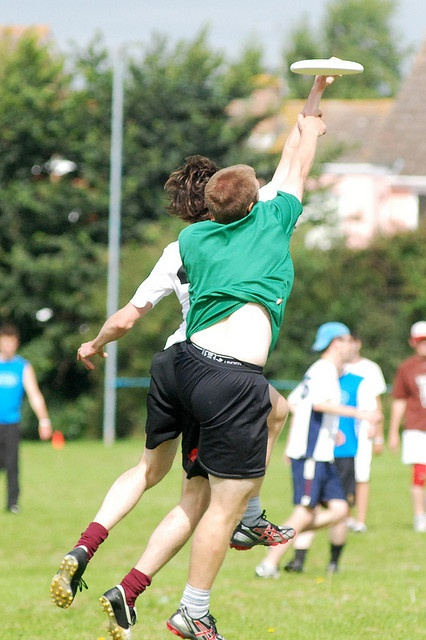Describe the objects in this image and their specific colors. I can see people in lightgray, black, white, turquoise, and gray tones, people in lightgray, white, black, and olive tones, people in lightblue, white, blue, and tan tones, people in lightblue, gray, and lightgray tones, and people in lightblue, white, brown, salmon, and tan tones in this image. 